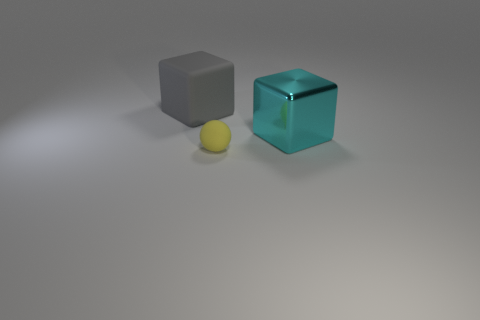Add 1 tiny gray rubber things. How many objects exist? 4 Subtract all balls. How many objects are left? 2 Add 3 cyan metallic objects. How many cyan metallic objects are left? 4 Add 1 rubber cubes. How many rubber cubes exist? 2 Subtract 0 brown balls. How many objects are left? 3 Subtract all brown matte cubes. Subtract all gray blocks. How many objects are left? 2 